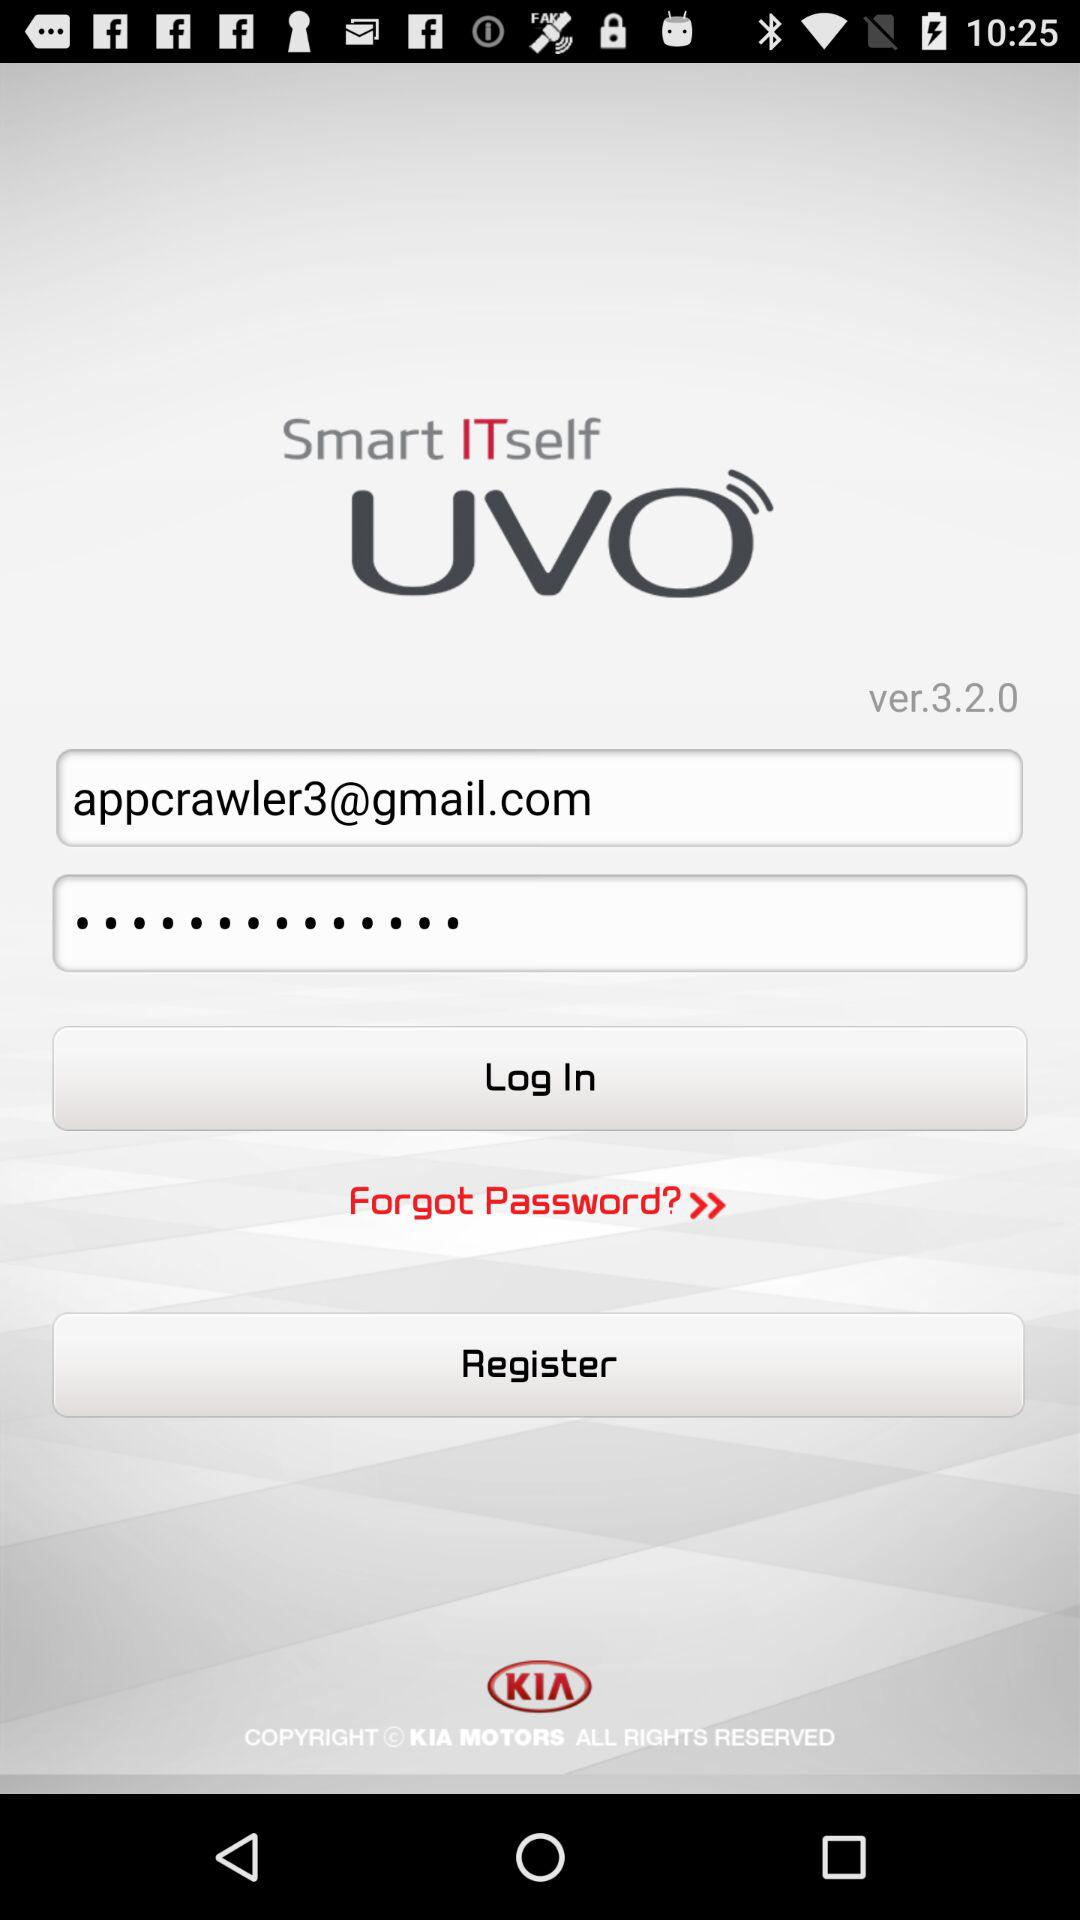What version is available? The available version is 3.2.0. 